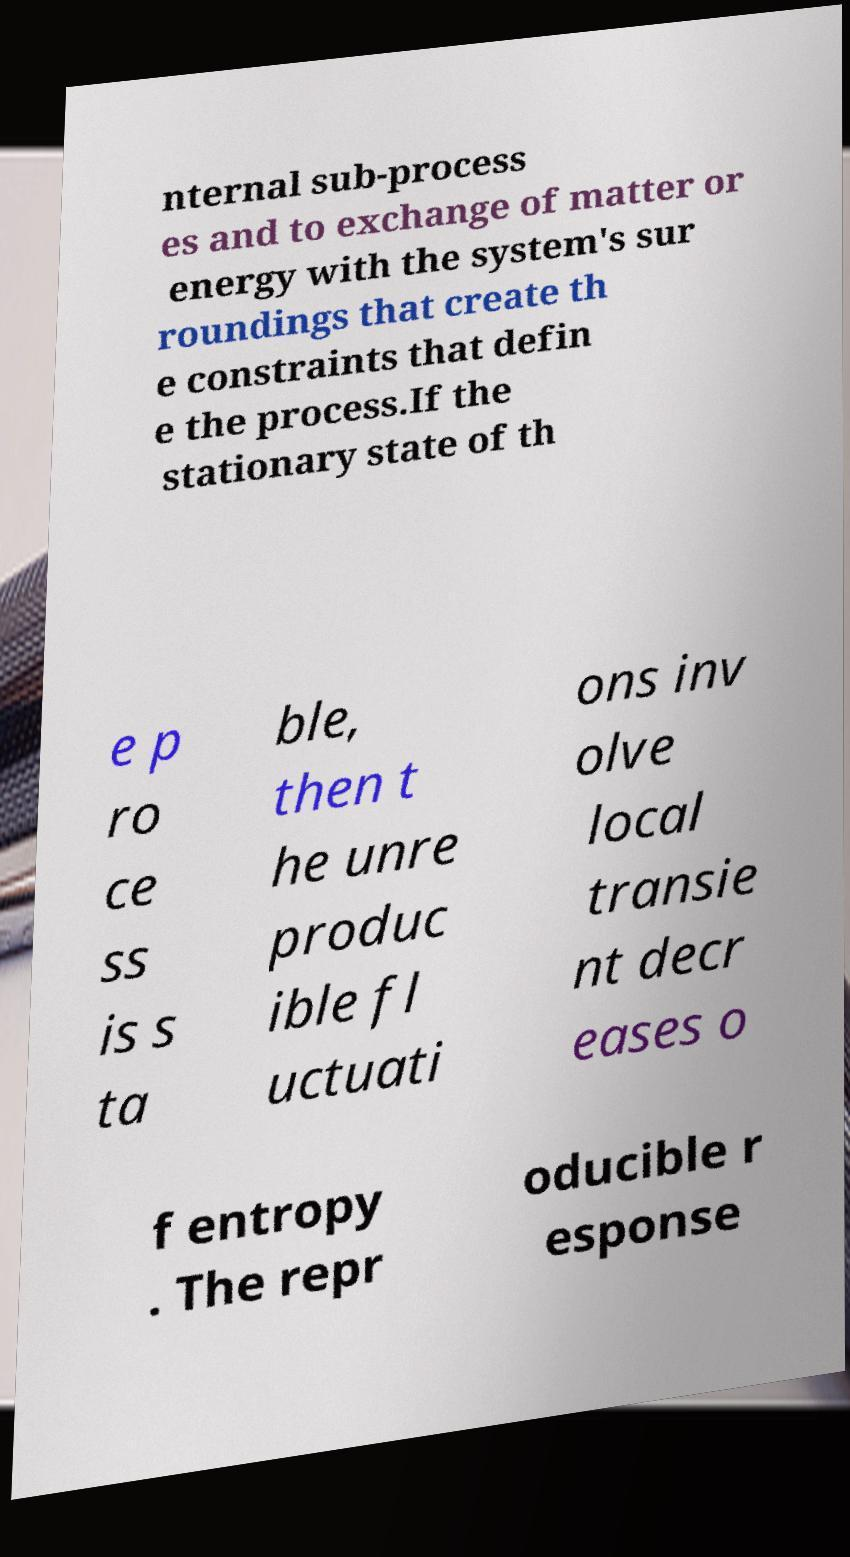Can you read and provide the text displayed in the image?This photo seems to have some interesting text. Can you extract and type it out for me? nternal sub-process es and to exchange of matter or energy with the system's sur roundings that create th e constraints that defin e the process.If the stationary state of th e p ro ce ss is s ta ble, then t he unre produc ible fl uctuati ons inv olve local transie nt decr eases o f entropy . The repr oducible r esponse 